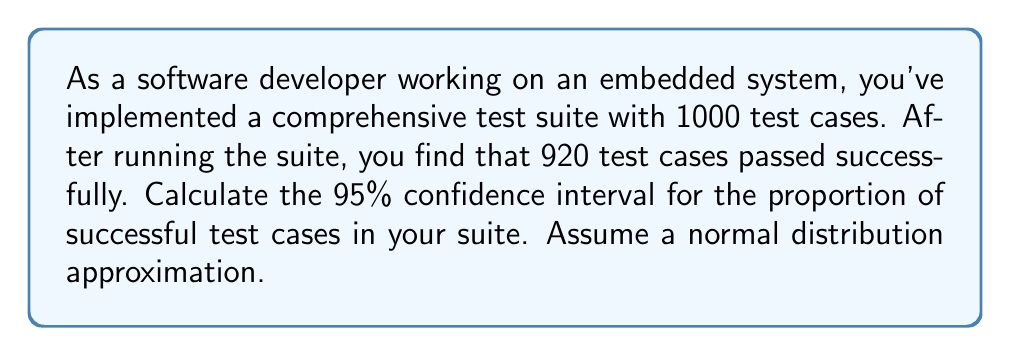Can you answer this question? Let's approach this step-by-step:

1) First, we need to identify our variables:
   $n$ = sample size = 1000
   $\hat{p}$ = sample proportion = 920/1000 = 0.92
   Confidence level = 95%, so $z_{\alpha/2}$ = 1.96

2) The formula for the confidence interval of a proportion is:

   $$\hat{p} \pm z_{\alpha/2} \sqrt{\frac{\hat{p}(1-\hat{p})}{n}}$$

3) Let's calculate the standard error:
   $$SE = \sqrt{\frac{\hat{p}(1-\hat{p})}{n}} = \sqrt{\frac{0.92(1-0.92)}{1000}} = \sqrt{\frac{0.0736}{1000}} = 0.00857$$

4) Now, we can calculate the margin of error:
   $$ME = z_{\alpha/2} * SE = 1.96 * 0.00857 = 0.01680$$

5) Finally, we can compute the confidence interval:
   Lower bound: $0.92 - 0.01680 = 0.90320$
   Upper bound: $0.92 + 0.01680 = 0.93680$

6) Therefore, we are 95% confident that the true proportion of successful test cases in the entire test suite lies between 0.90320 and 0.93680.

Note: In the context of embedded systems, this confidence interval is crucial for assessing the reliability of the software and identifying potential areas for improvement in the codebase or test suite.
Answer: (0.90320, 0.93680) 